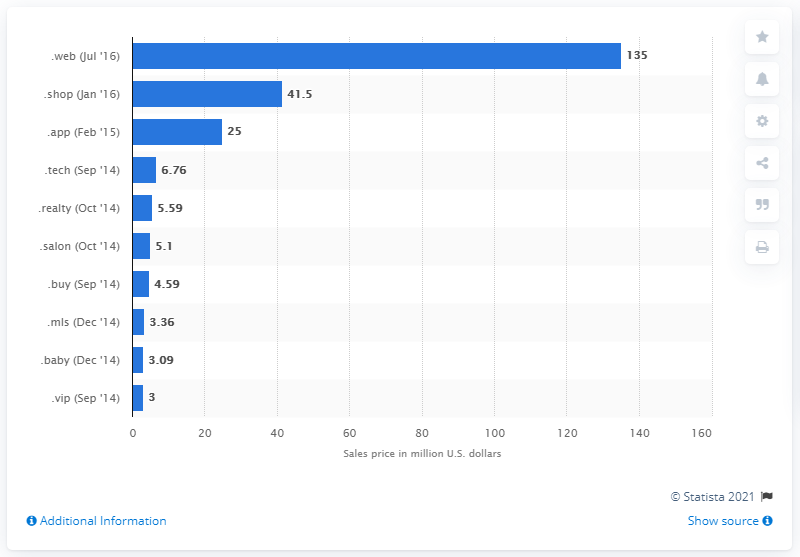Mention a couple of crucial points in this snapshot. Amazon spent $4.59 on the gTLD.buy in September 2014. Google paid $25 for the .app domain. 